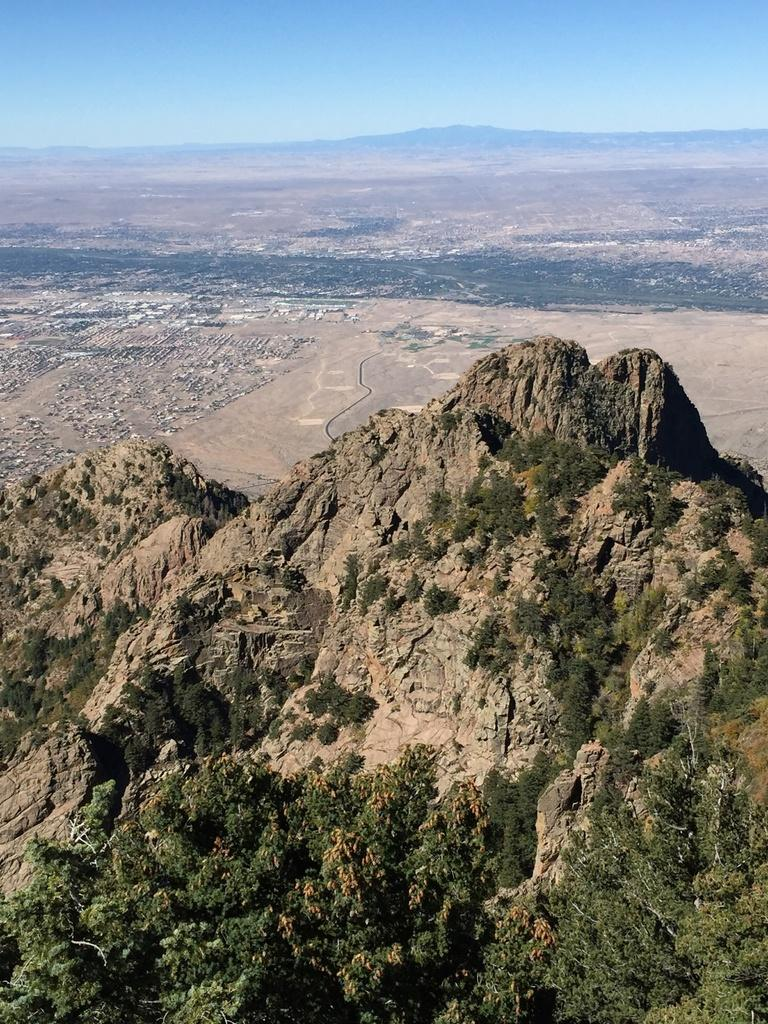What is located in the center of the image? There are trees and a hill in the center of the image. What can be seen in the background of the image? The sky, another hill, and grass are visible in the background of the image. What is the ground like in the background of the image? The ground is visible in the background of the image. What type of joke is being told by the trees in the image? There are no jokes being told in the image; it features trees, hills, and a sky. What type of plot is being developed by the grass in the image? There is no plot being developed by the grass in the image; it is simply a part of the natural landscape. 